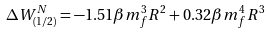<formula> <loc_0><loc_0><loc_500><loc_500>\Delta W _ { ( 1 / 2 ) } ^ { N } = - 1 . 5 1 \beta m _ { f } ^ { 3 } R ^ { 2 } + 0 . 3 2 \beta m _ { f } ^ { 4 } R ^ { 3 }</formula> 